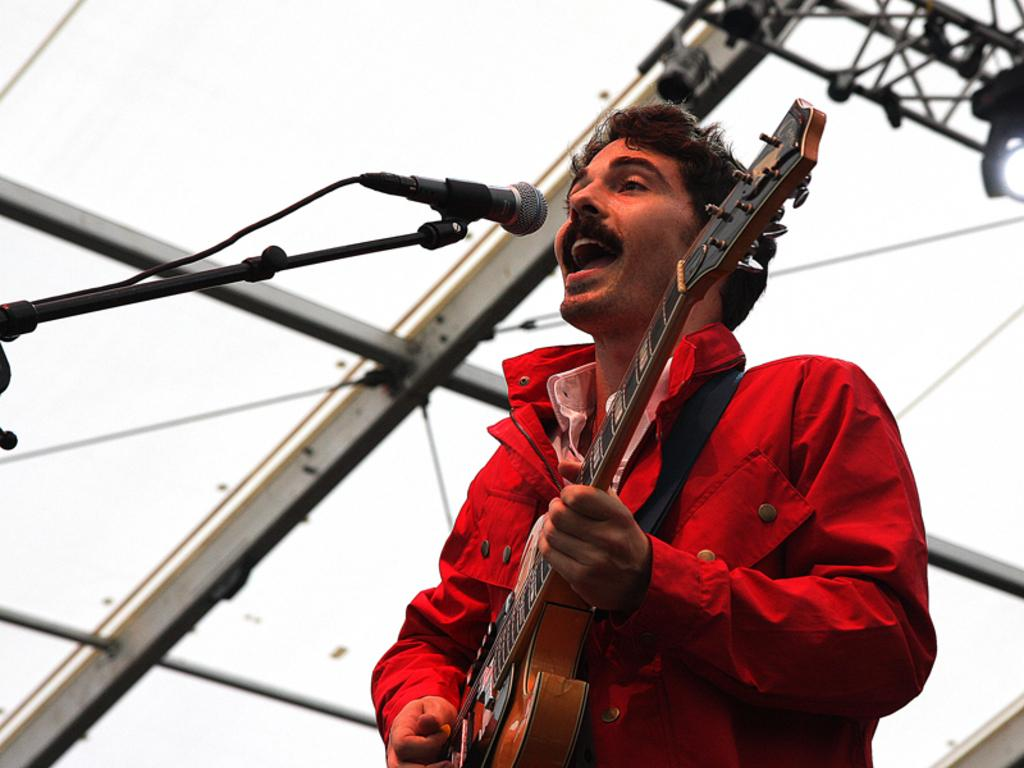What is the person in the image doing? The person is playing a guitar and singing. What object is the person using to amplify their voice? The person is in front of a microphone. What can be seen in the background of the image? There are rods and focusing lights in the background. What type of silk fabric is draped over the guitar in the image? There is no silk fabric present in the image; the guitar is not covered by any fabric. 